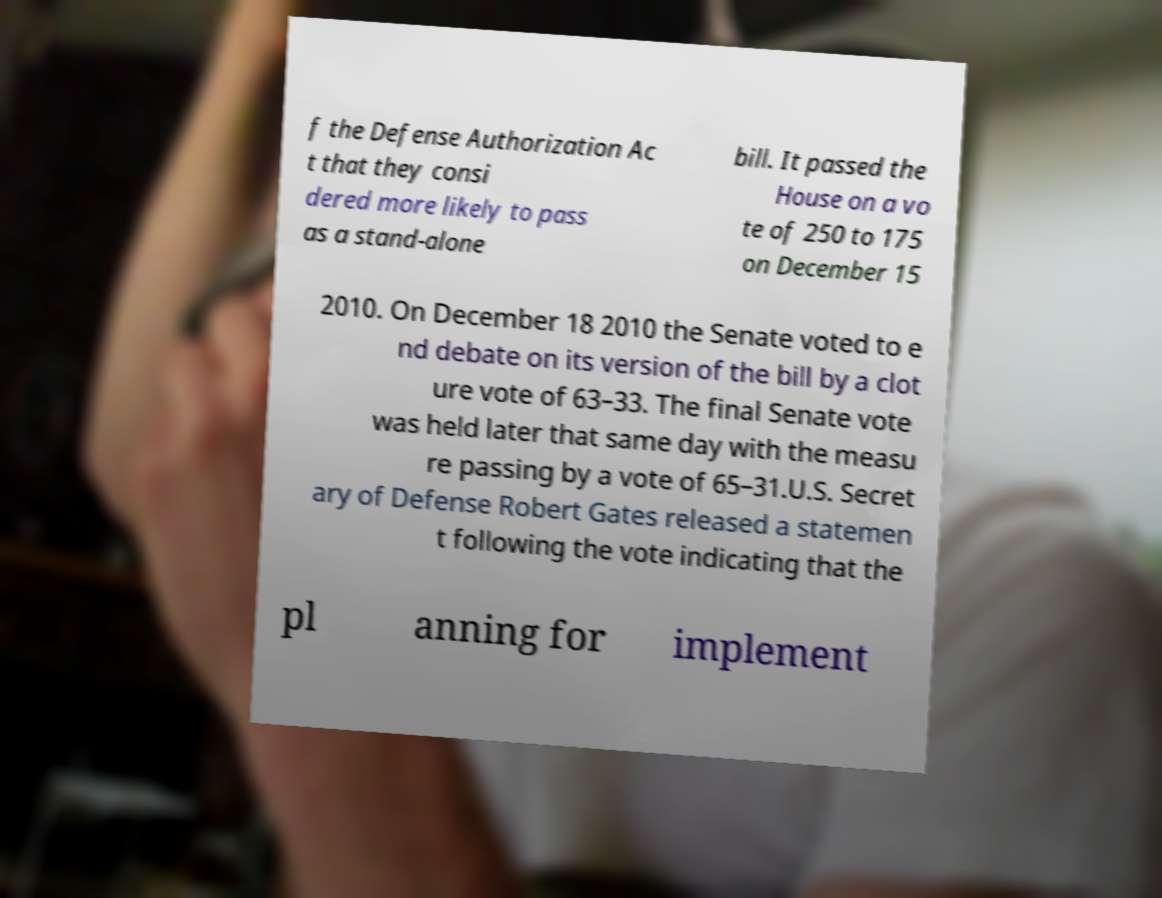Please read and relay the text visible in this image. What does it say? f the Defense Authorization Ac t that they consi dered more likely to pass as a stand-alone bill. It passed the House on a vo te of 250 to 175 on December 15 2010. On December 18 2010 the Senate voted to e nd debate on its version of the bill by a clot ure vote of 63–33. The final Senate vote was held later that same day with the measu re passing by a vote of 65–31.U.S. Secret ary of Defense Robert Gates released a statemen t following the vote indicating that the pl anning for implement 